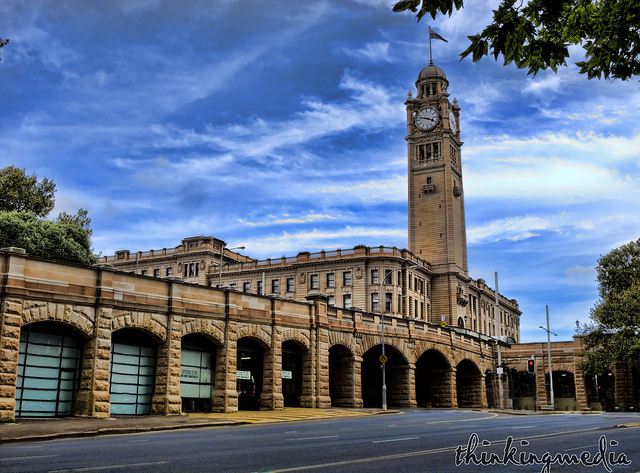Please transcribe the text information in this image. thinkingmedia 